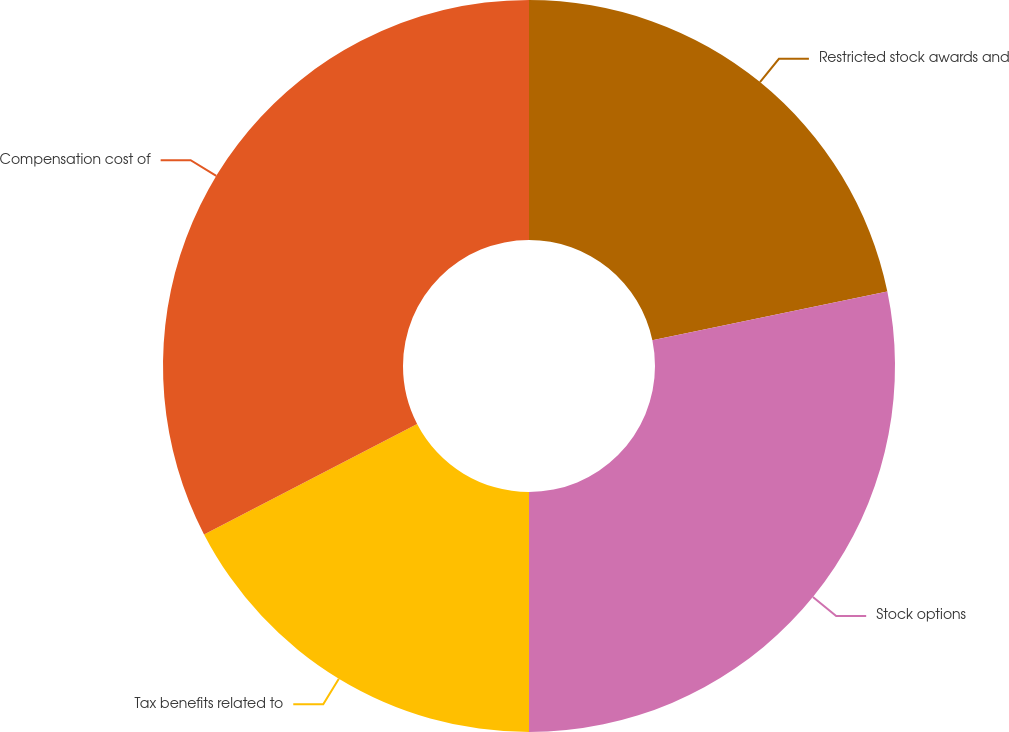Convert chart. <chart><loc_0><loc_0><loc_500><loc_500><pie_chart><fcel>Restricted stock awards and<fcel>Stock options<fcel>Tax benefits related to<fcel>Compensation cost of<nl><fcel>21.74%<fcel>28.26%<fcel>17.39%<fcel>32.61%<nl></chart> 